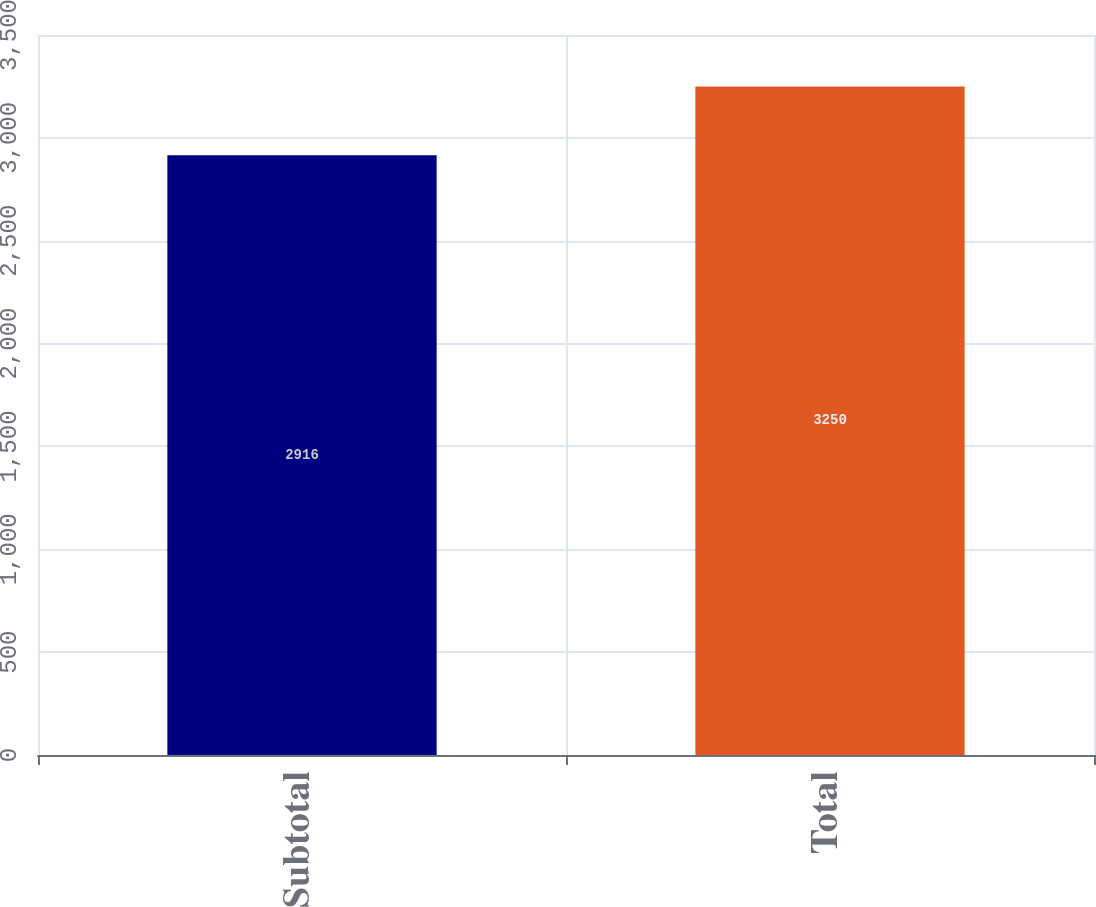Convert chart to OTSL. <chart><loc_0><loc_0><loc_500><loc_500><bar_chart><fcel>Subtotal<fcel>Total<nl><fcel>2916<fcel>3250<nl></chart> 